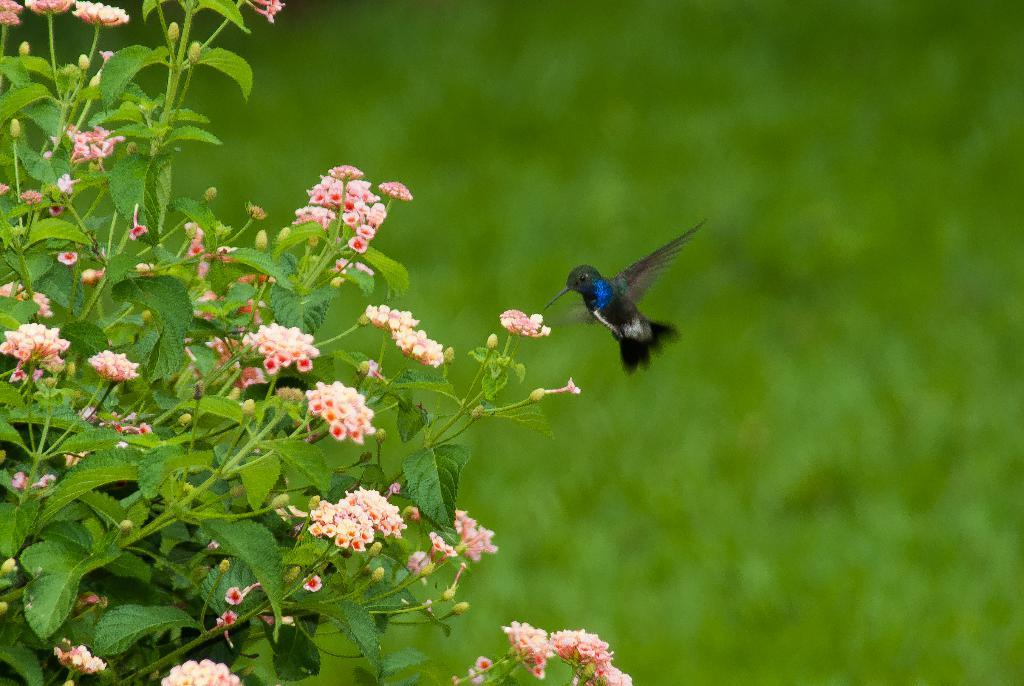What type of living organisms can be seen in the image? Plants and flowers are visible in the image. What is the bird doing in the image? There is a bird flying in the air in the image. What type of surface is at the bottom of the image? There is grass on the surface at the bottom of the image. What type of gun can be seen in the image? There is no gun present in the image. Is there any blood visible in the image? There is no blood visible in the image. 